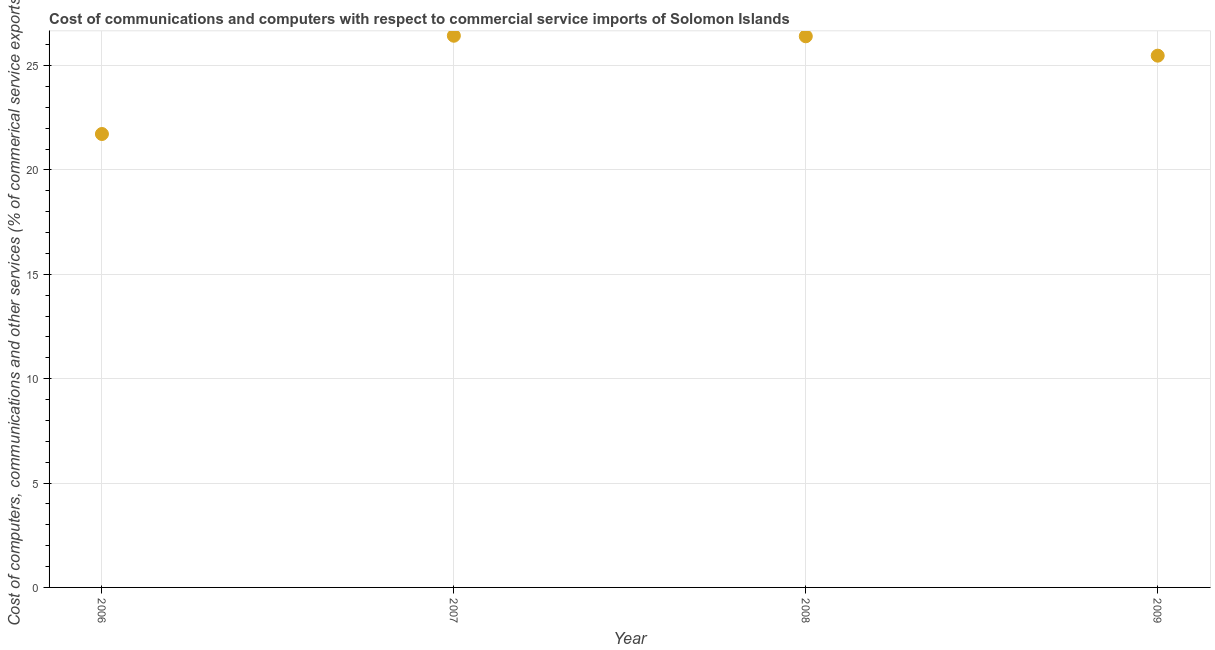What is the cost of communications in 2009?
Make the answer very short. 25.47. Across all years, what is the maximum  computer and other services?
Keep it short and to the point. 26.43. Across all years, what is the minimum cost of communications?
Provide a short and direct response. 21.72. What is the sum of the  computer and other services?
Provide a succinct answer. 100.02. What is the difference between the  computer and other services in 2006 and 2008?
Give a very brief answer. -4.68. What is the average cost of communications per year?
Provide a short and direct response. 25.01. What is the median  computer and other services?
Offer a terse response. 25.94. In how many years, is the cost of communications greater than 16 %?
Provide a succinct answer. 4. Do a majority of the years between 2009 and 2006 (inclusive) have  computer and other services greater than 21 %?
Provide a succinct answer. Yes. What is the ratio of the cost of communications in 2006 to that in 2008?
Keep it short and to the point. 0.82. Is the  computer and other services in 2006 less than that in 2009?
Ensure brevity in your answer.  Yes. Is the difference between the cost of communications in 2006 and 2007 greater than the difference between any two years?
Ensure brevity in your answer.  Yes. What is the difference between the highest and the second highest cost of communications?
Keep it short and to the point. 0.03. What is the difference between the highest and the lowest  computer and other services?
Keep it short and to the point. 4.71. How many years are there in the graph?
Ensure brevity in your answer.  4. What is the title of the graph?
Provide a succinct answer. Cost of communications and computers with respect to commercial service imports of Solomon Islands. What is the label or title of the X-axis?
Provide a succinct answer. Year. What is the label or title of the Y-axis?
Ensure brevity in your answer.  Cost of computers, communications and other services (% of commerical service exports). What is the Cost of computers, communications and other services (% of commerical service exports) in 2006?
Your answer should be compact. 21.72. What is the Cost of computers, communications and other services (% of commerical service exports) in 2007?
Your answer should be compact. 26.43. What is the Cost of computers, communications and other services (% of commerical service exports) in 2008?
Offer a terse response. 26.4. What is the Cost of computers, communications and other services (% of commerical service exports) in 2009?
Give a very brief answer. 25.47. What is the difference between the Cost of computers, communications and other services (% of commerical service exports) in 2006 and 2007?
Make the answer very short. -4.71. What is the difference between the Cost of computers, communications and other services (% of commerical service exports) in 2006 and 2008?
Provide a succinct answer. -4.68. What is the difference between the Cost of computers, communications and other services (% of commerical service exports) in 2006 and 2009?
Ensure brevity in your answer.  -3.75. What is the difference between the Cost of computers, communications and other services (% of commerical service exports) in 2007 and 2008?
Make the answer very short. 0.03. What is the difference between the Cost of computers, communications and other services (% of commerical service exports) in 2007 and 2009?
Ensure brevity in your answer.  0.95. What is the difference between the Cost of computers, communications and other services (% of commerical service exports) in 2008 and 2009?
Your response must be concise. 0.93. What is the ratio of the Cost of computers, communications and other services (% of commerical service exports) in 2006 to that in 2007?
Keep it short and to the point. 0.82. What is the ratio of the Cost of computers, communications and other services (% of commerical service exports) in 2006 to that in 2008?
Offer a very short reply. 0.82. What is the ratio of the Cost of computers, communications and other services (% of commerical service exports) in 2006 to that in 2009?
Make the answer very short. 0.85. What is the ratio of the Cost of computers, communications and other services (% of commerical service exports) in 2008 to that in 2009?
Offer a very short reply. 1.04. 